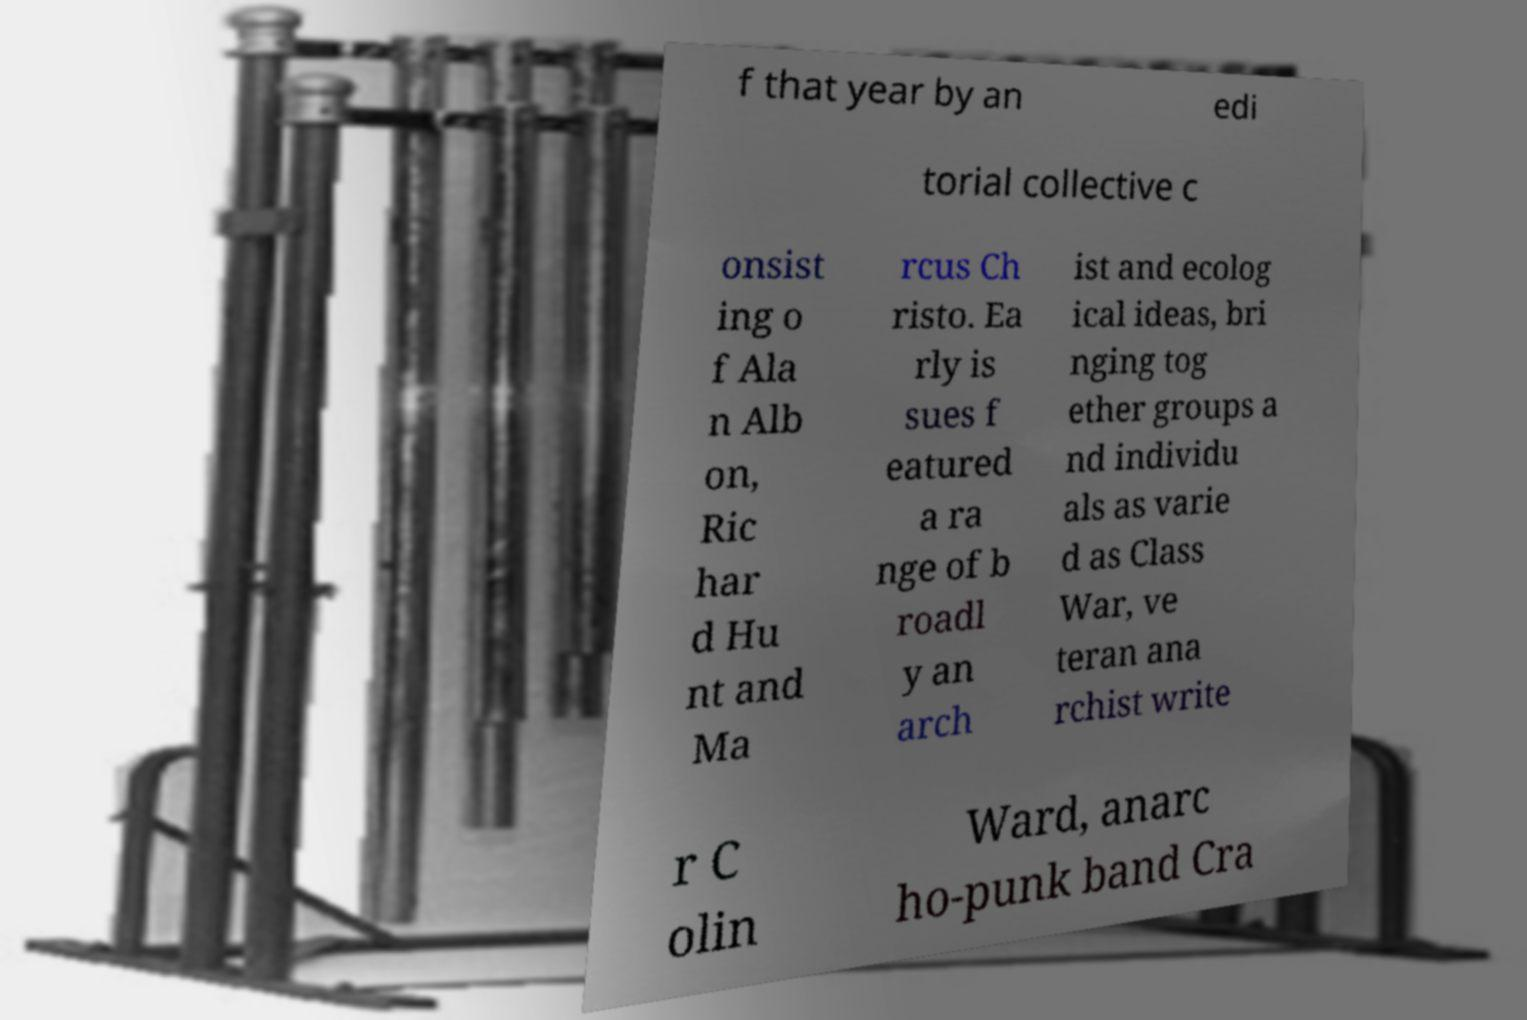There's text embedded in this image that I need extracted. Can you transcribe it verbatim? f that year by an edi torial collective c onsist ing o f Ala n Alb on, Ric har d Hu nt and Ma rcus Ch risto. Ea rly is sues f eatured a ra nge of b roadl y an arch ist and ecolog ical ideas, bri nging tog ether groups a nd individu als as varie d as Class War, ve teran ana rchist write r C olin Ward, anarc ho-punk band Cra 